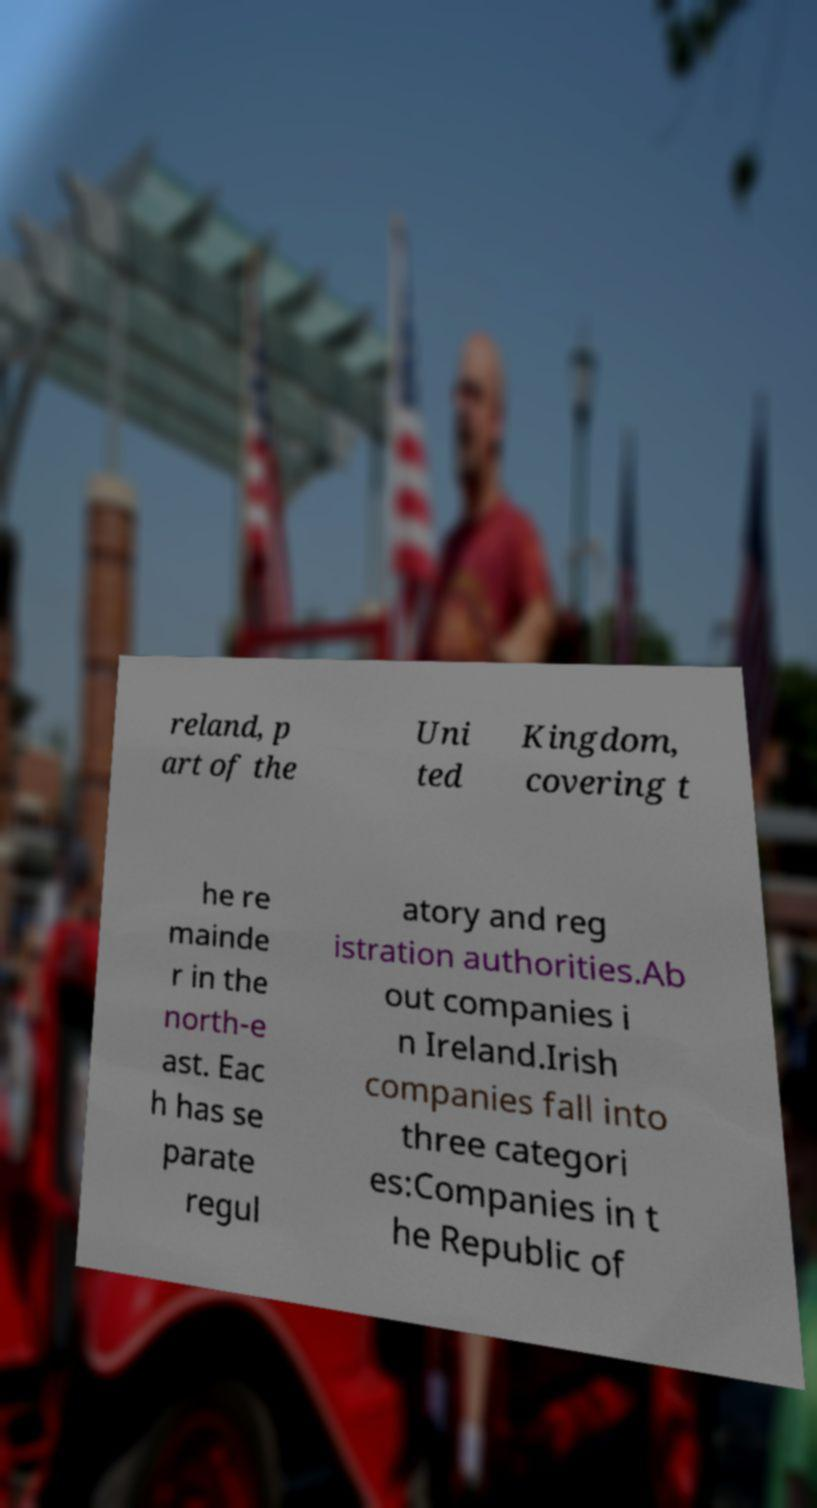I need the written content from this picture converted into text. Can you do that? reland, p art of the Uni ted Kingdom, covering t he re mainde r in the north-e ast. Eac h has se parate regul atory and reg istration authorities.Ab out companies i n Ireland.Irish companies fall into three categori es:Companies in t he Republic of 